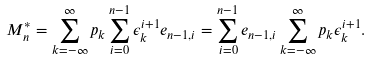Convert formula to latex. <formula><loc_0><loc_0><loc_500><loc_500>M _ { n } ^ { * } = \sum _ { k = - \infty } ^ { \infty } p _ { k } \sum _ { i = 0 } ^ { n - 1 } \epsilon _ { k } ^ { i + 1 } e _ { n - 1 , i } = \sum _ { i = 0 } ^ { n - 1 } e _ { n - 1 , i } \sum _ { k = - \infty } ^ { \infty } p _ { k } \epsilon _ { k } ^ { i + 1 } .</formula> 